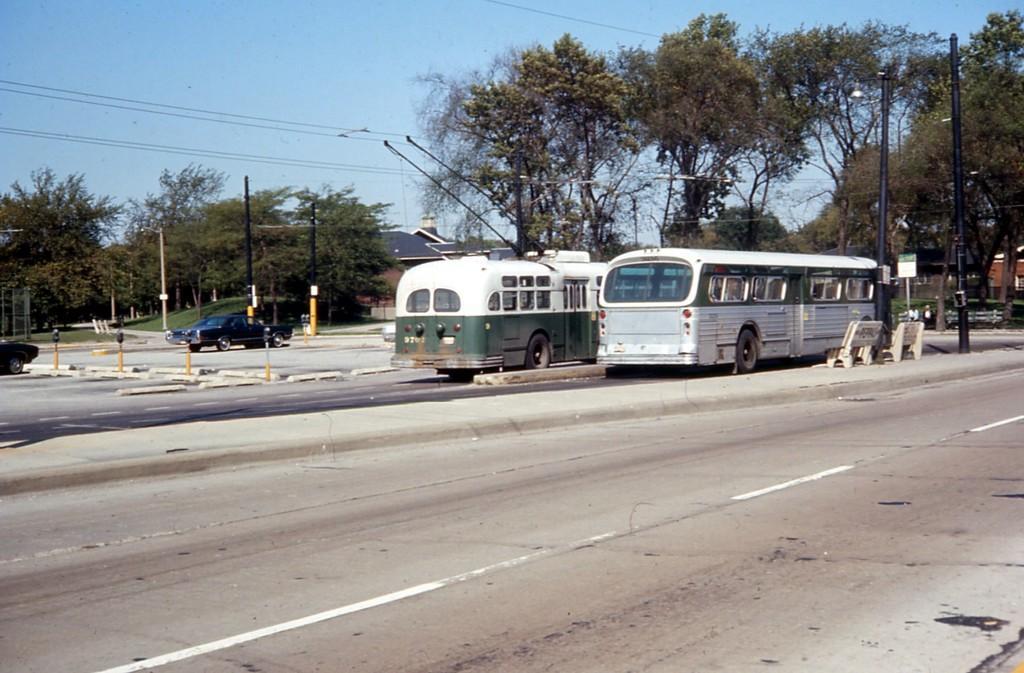Can you describe this image briefly? In this image I can see the electric poles. I can also see the vehicles on the road. In the background, I can see the trees, buildings and the sky. 